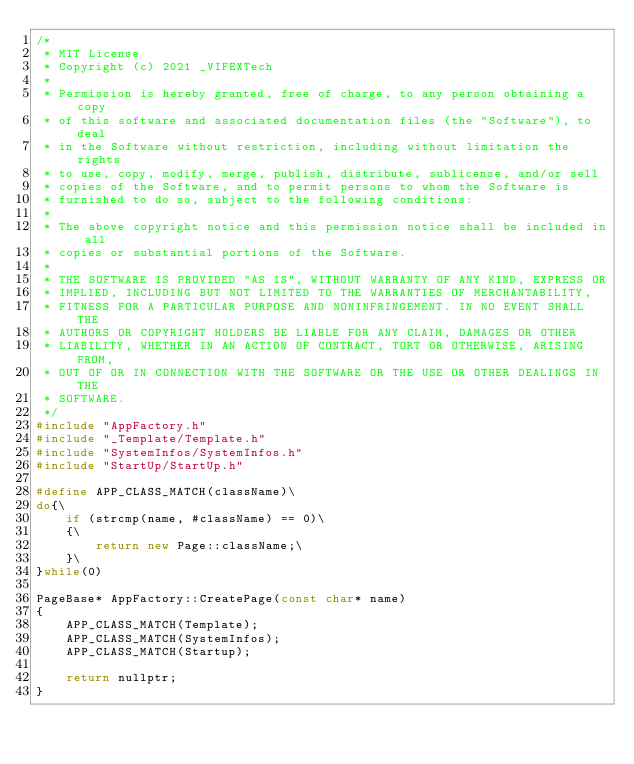<code> <loc_0><loc_0><loc_500><loc_500><_C++_>/*
 * MIT License
 * Copyright (c) 2021 _VIFEXTech
 *
 * Permission is hereby granted, free of charge, to any person obtaining a copy
 * of this software and associated documentation files (the "Software"), to deal
 * in the Software without restriction, including without limitation the rights
 * to use, copy, modify, merge, publish, distribute, sublicense, and/or sell
 * copies of the Software, and to permit persons to whom the Software is
 * furnished to do so, subject to the following conditions:
 *
 * The above copyright notice and this permission notice shall be included in all
 * copies or substantial portions of the Software.
 *
 * THE SOFTWARE IS PROVIDED "AS IS", WITHOUT WARRANTY OF ANY KIND, EXPRESS OR
 * IMPLIED, INCLUDING BUT NOT LIMITED TO THE WARRANTIES OF MERCHANTABILITY,
 * FITNESS FOR A PARTICULAR PURPOSE AND NONINFRINGEMENT. IN NO EVENT SHALL THE
 * AUTHORS OR COPYRIGHT HOLDERS BE LIABLE FOR ANY CLAIM, DAMAGES OR OTHER
 * LIABILITY, WHETHER IN AN ACTION OF CONTRACT, TORT OR OTHERWISE, ARISING FROM,
 * OUT OF OR IN CONNECTION WITH THE SOFTWARE OR THE USE OR OTHER DEALINGS IN THE
 * SOFTWARE.
 */
#include "AppFactory.h"
#include "_Template/Template.h"
#include "SystemInfos/SystemInfos.h"
#include "StartUp/StartUp.h"

#define APP_CLASS_MATCH(className)\
do{\
    if (strcmp(name, #className) == 0)\
    {\
        return new Page::className;\
    }\
}while(0)

PageBase* AppFactory::CreatePage(const char* name)
{
    APP_CLASS_MATCH(Template);
    APP_CLASS_MATCH(SystemInfos);
    APP_CLASS_MATCH(Startup);

    return nullptr;
}
</code> 